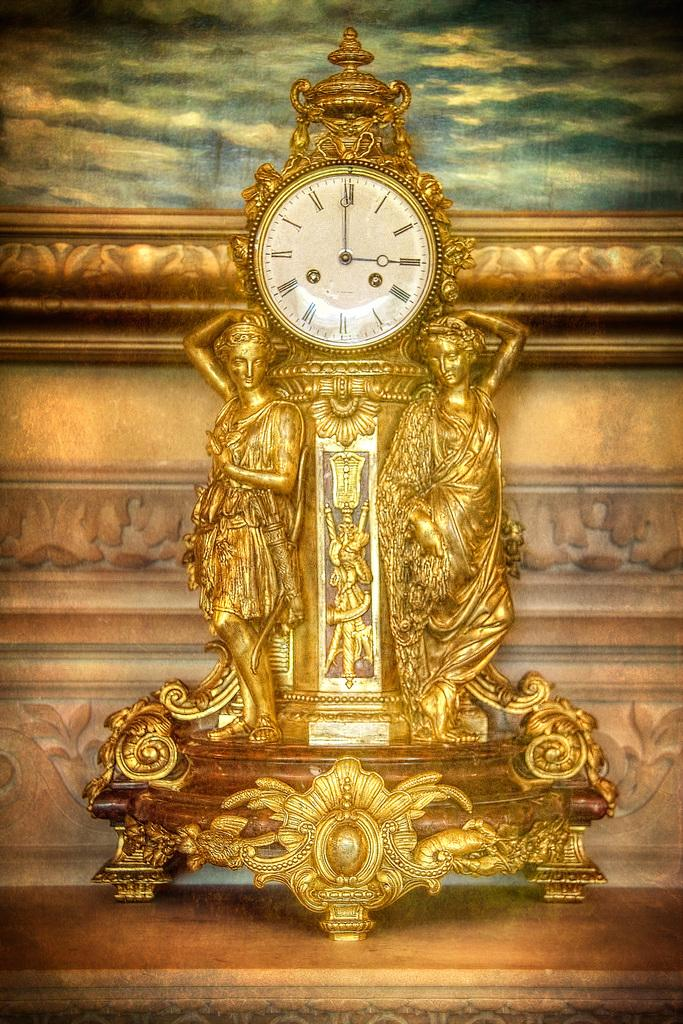What is the main object in the center of the image? There is a table in the center of the image. What is placed on the table? There is a clock and sculptures on the table. What can be seen in the background of the image? There is a wall and a photo frame in the background of the image. How does the governor interact with the clock in the image? There is no governor present in the image, and therefore no interaction can be observed. 